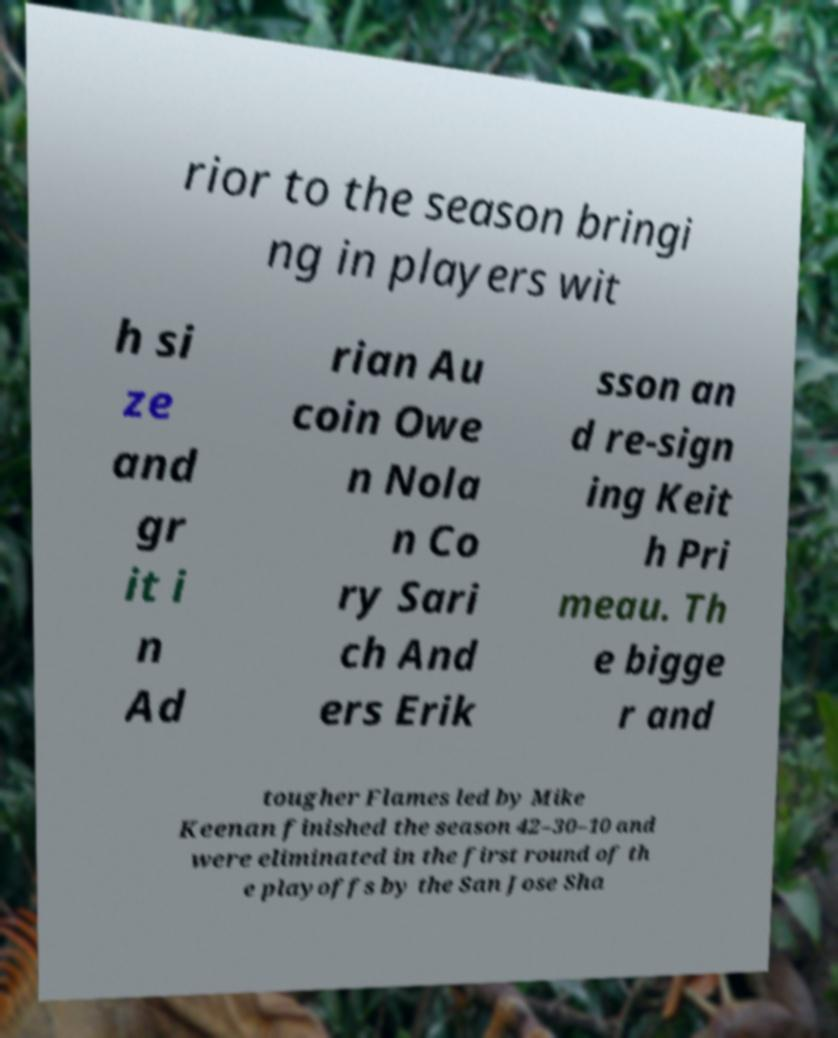Please identify and transcribe the text found in this image. rior to the season bringi ng in players wit h si ze and gr it i n Ad rian Au coin Owe n Nola n Co ry Sari ch And ers Erik sson an d re-sign ing Keit h Pri meau. Th e bigge r and tougher Flames led by Mike Keenan finished the season 42–30–10 and were eliminated in the first round of th e playoffs by the San Jose Sha 